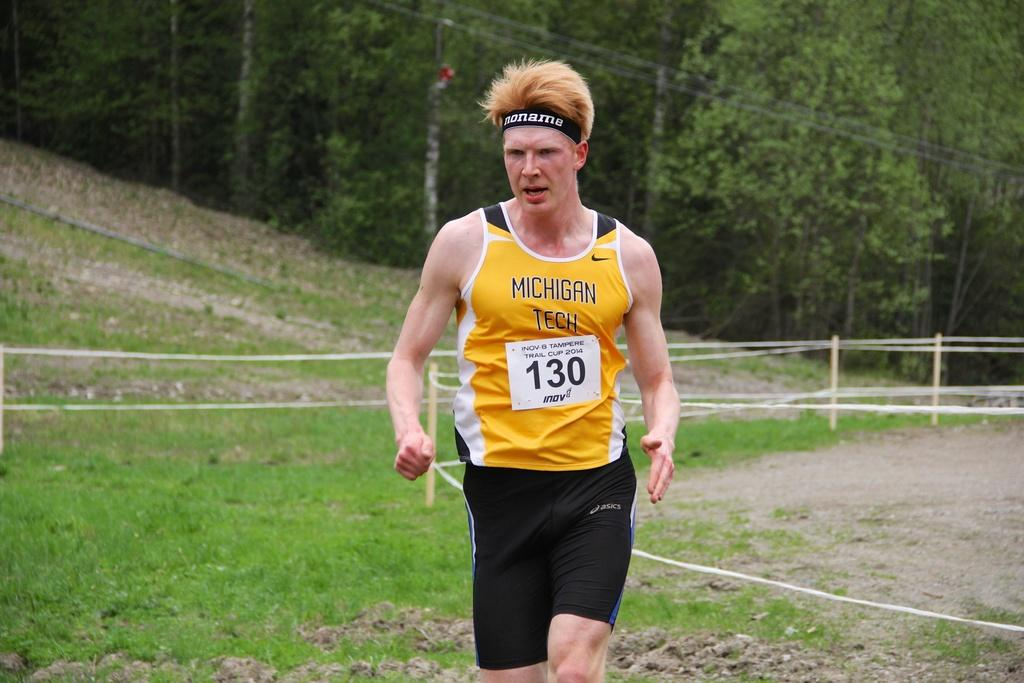What is the main subject of the image? There is a man in the image. What is the man doing in the image? The man is running in the image. On what type of surface is the man running? The man is running on a grass surface area. What color is the top the man is wearing? The man is wearing a yellow top. What is on the man's head in the image? The man has a band on his head. What can be seen in the background of the image? There is a grass surface and trees in the background of the image. What type of spoon is the man using to eat ice cream in the image? There is no spoon or ice cream present in the image; the man is running with a band on his head. What type of hat is the man wearing in the image? The man is not wearing a hat in the image; he has a band on his head. 